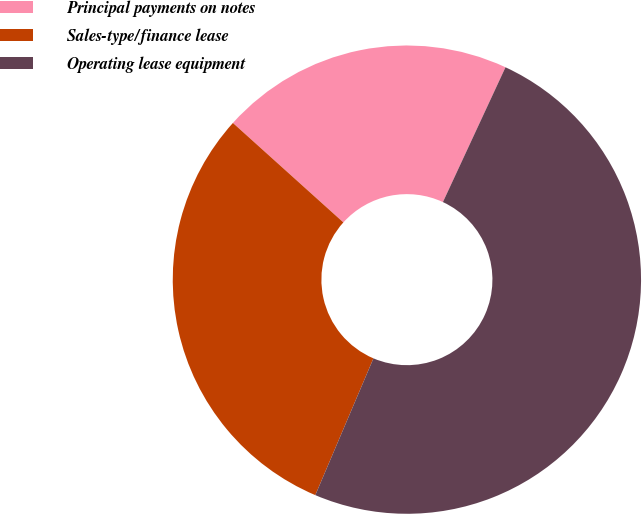Convert chart to OTSL. <chart><loc_0><loc_0><loc_500><loc_500><pie_chart><fcel>Principal payments on notes<fcel>Sales-type/finance lease<fcel>Operating lease equipment<nl><fcel>20.25%<fcel>30.27%<fcel>49.48%<nl></chart> 